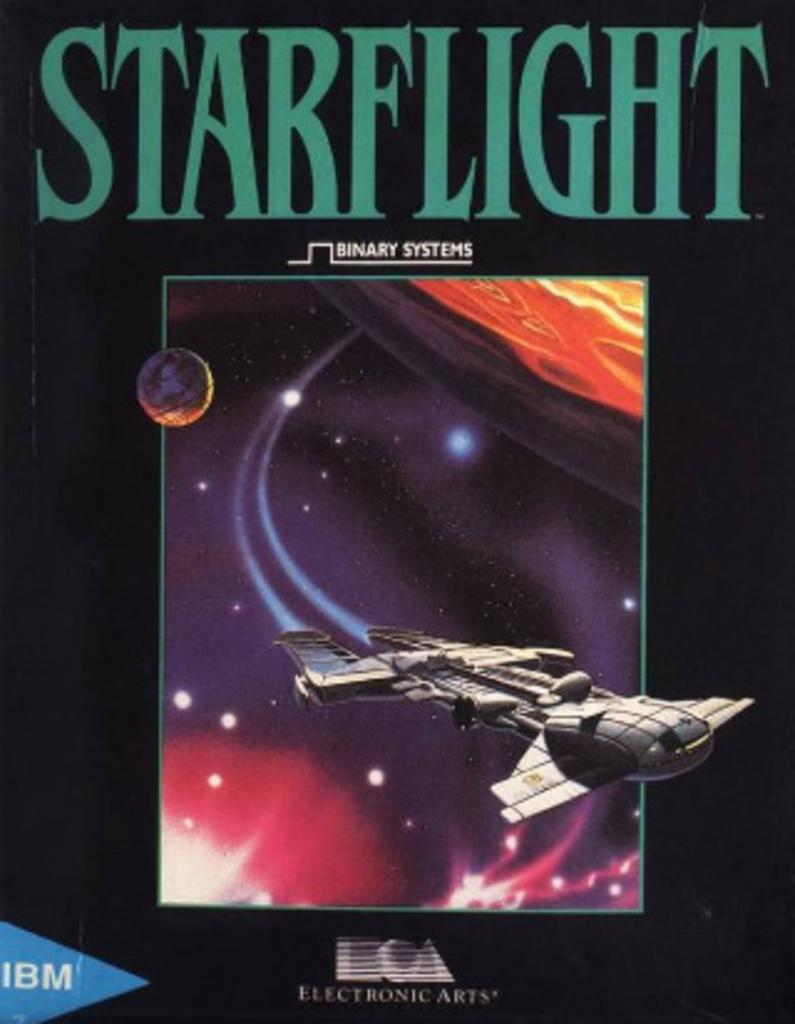<image>
Create a compact narrative representing the image presented. The cover of the IBM computer game Starflight. 